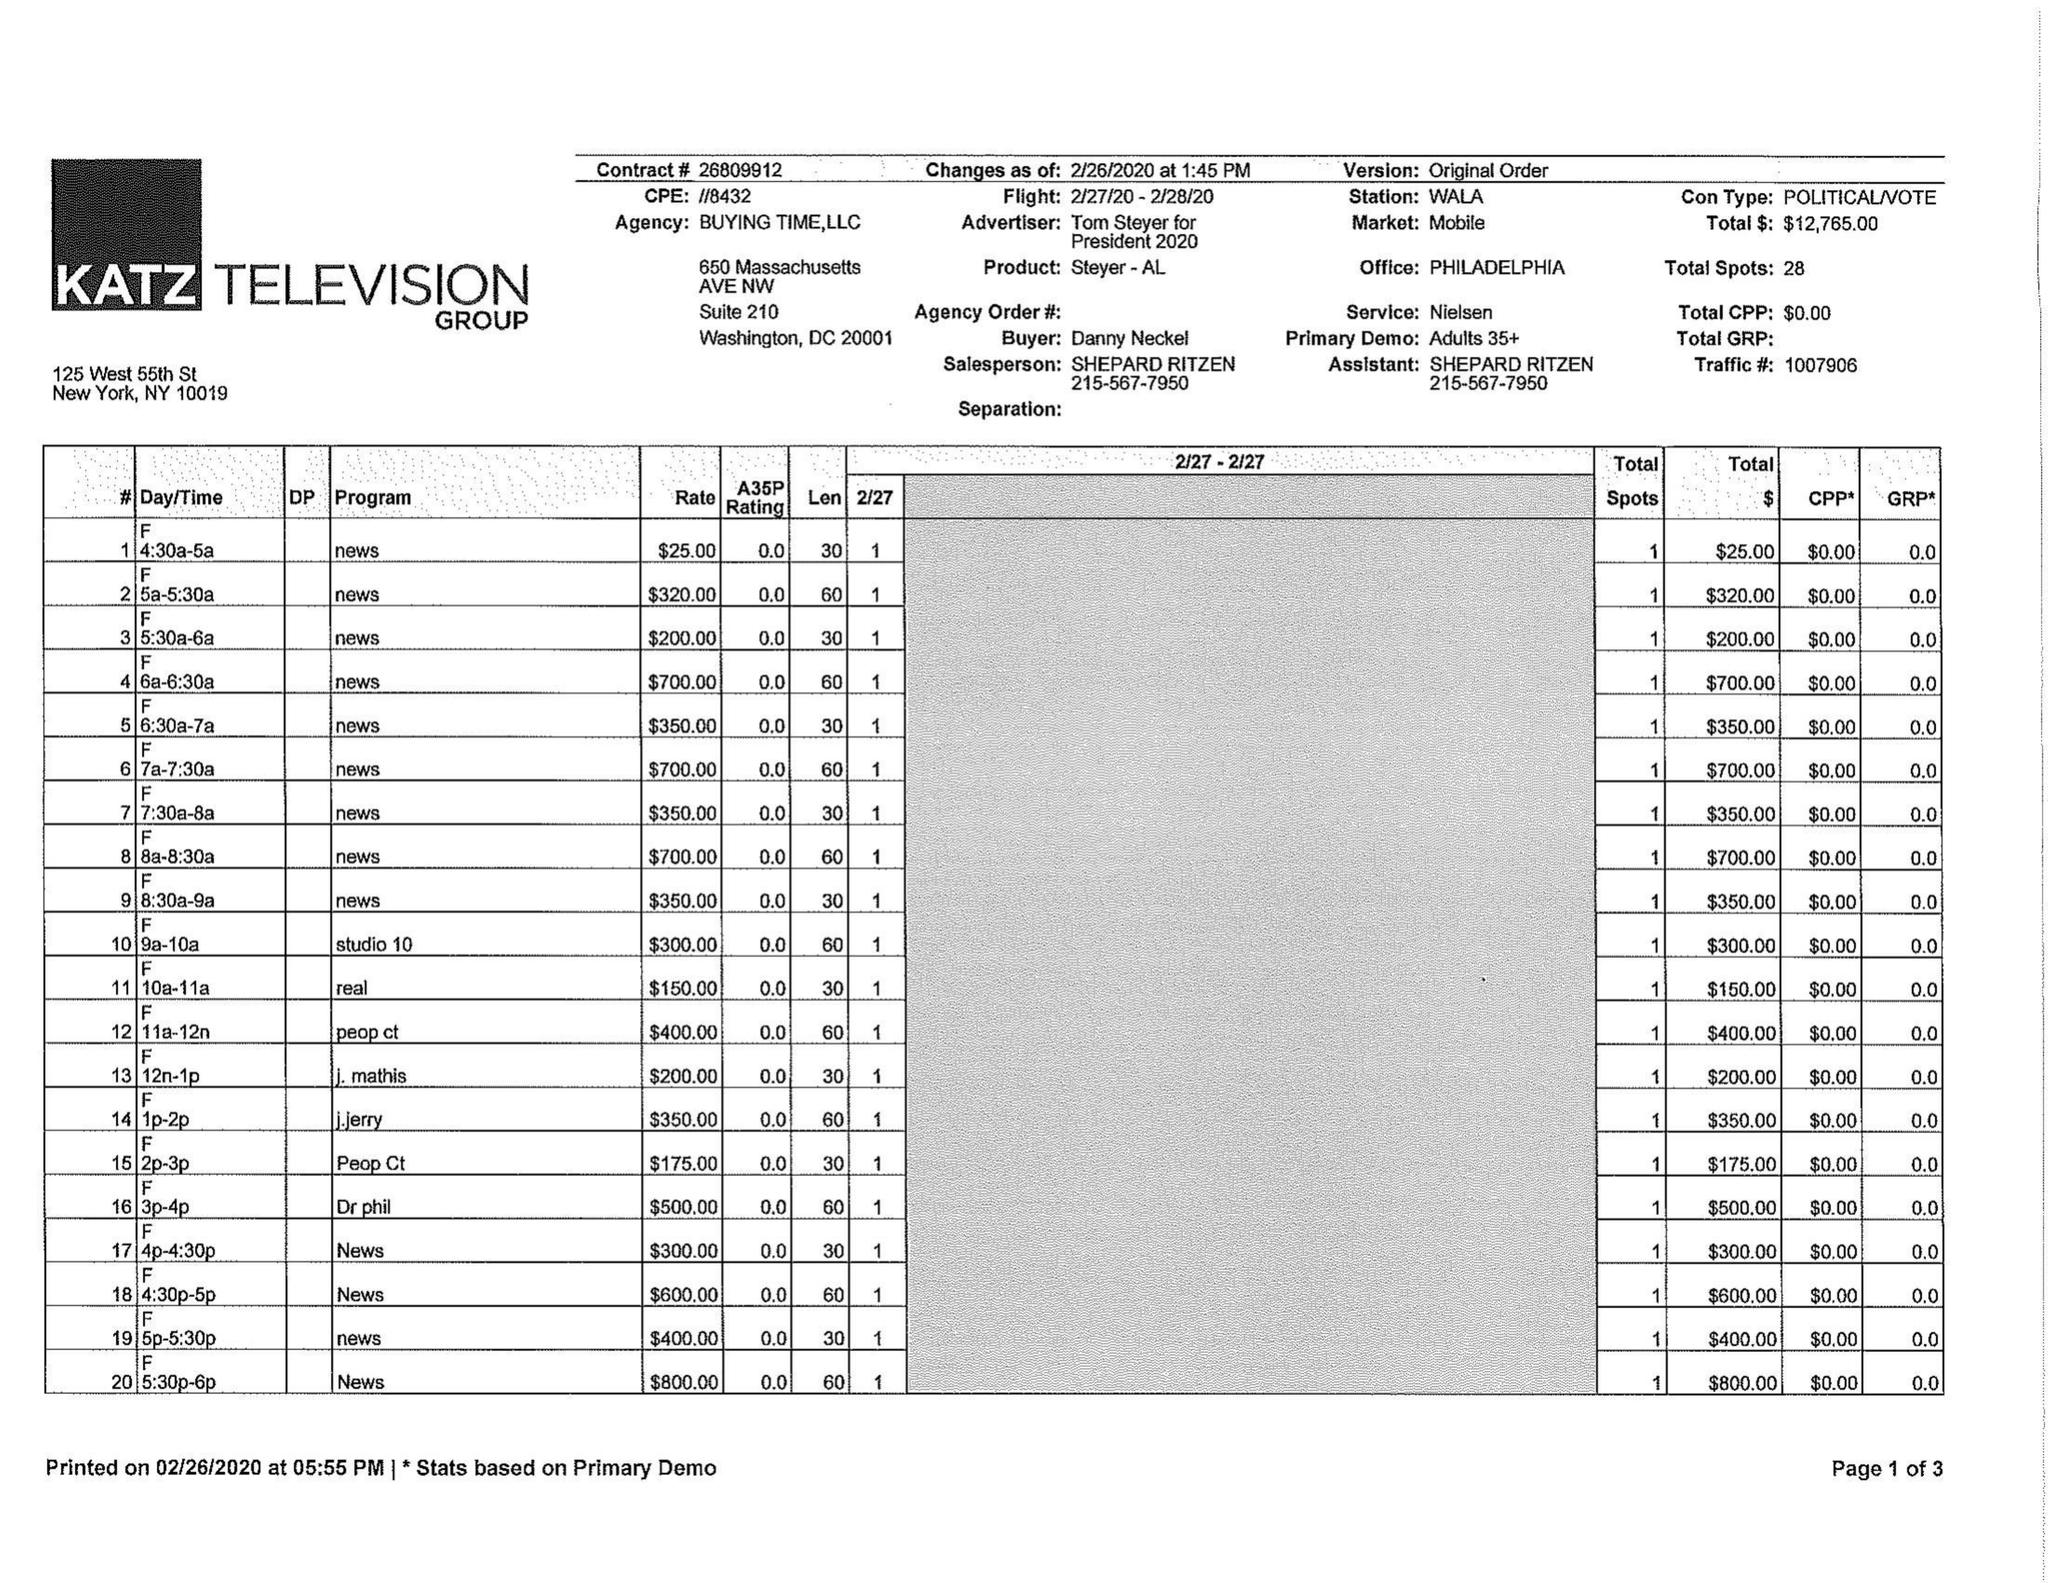What is the value for the flight_to?
Answer the question using a single word or phrase. 02/28/20 